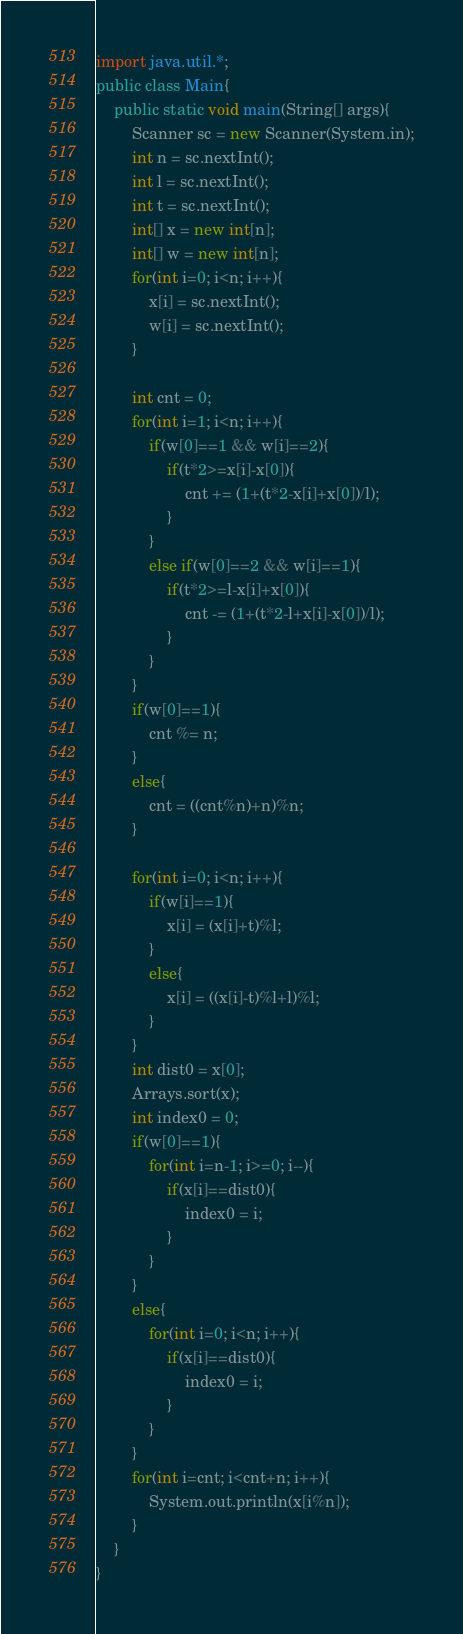Convert code to text. <code><loc_0><loc_0><loc_500><loc_500><_Java_>import java.util.*;
public class Main{
	public static void main(String[] args){
		Scanner sc = new Scanner(System.in);
		int n = sc.nextInt();
		int l = sc.nextInt();
		int t = sc.nextInt();
		int[] x = new int[n];
		int[] w = new int[n];
		for(int i=0; i<n; i++){
			x[i] = sc.nextInt();
			w[i] = sc.nextInt();
		}

		int cnt = 0;
		for(int i=1; i<n; i++){
			if(w[0]==1 && w[i]==2){
				if(t*2>=x[i]-x[0]){
					cnt += (1+(t*2-x[i]+x[0])/l);
				}
			}
			else if(w[0]==2 && w[i]==1){
				if(t*2>=l-x[i]+x[0]){
					cnt -= (1+(t*2-l+x[i]-x[0])/l);
				}
			}
		}
		if(w[0]==1){
			cnt %= n;
		}
		else{
			cnt = ((cnt%n)+n)%n;
		}

		for(int i=0; i<n; i++){
			if(w[i]==1){
				x[i] = (x[i]+t)%l;
			}
			else{
				x[i] = ((x[i]-t)%l+l)%l;
			}
		}
		int dist0 = x[0];
		Arrays.sort(x);
		int index0 = 0;
		if(w[0]==1){
			for(int i=n-1; i>=0; i--){
				if(x[i]==dist0){
					index0 = i;
				}
			}
		}
		else{
			for(int i=0; i<n; i++){
				if(x[i]==dist0){
					index0 = i;
				}
			}
		}
		for(int i=cnt; i<cnt+n; i++){
			System.out.println(x[i%n]);
		}
	}
}</code> 